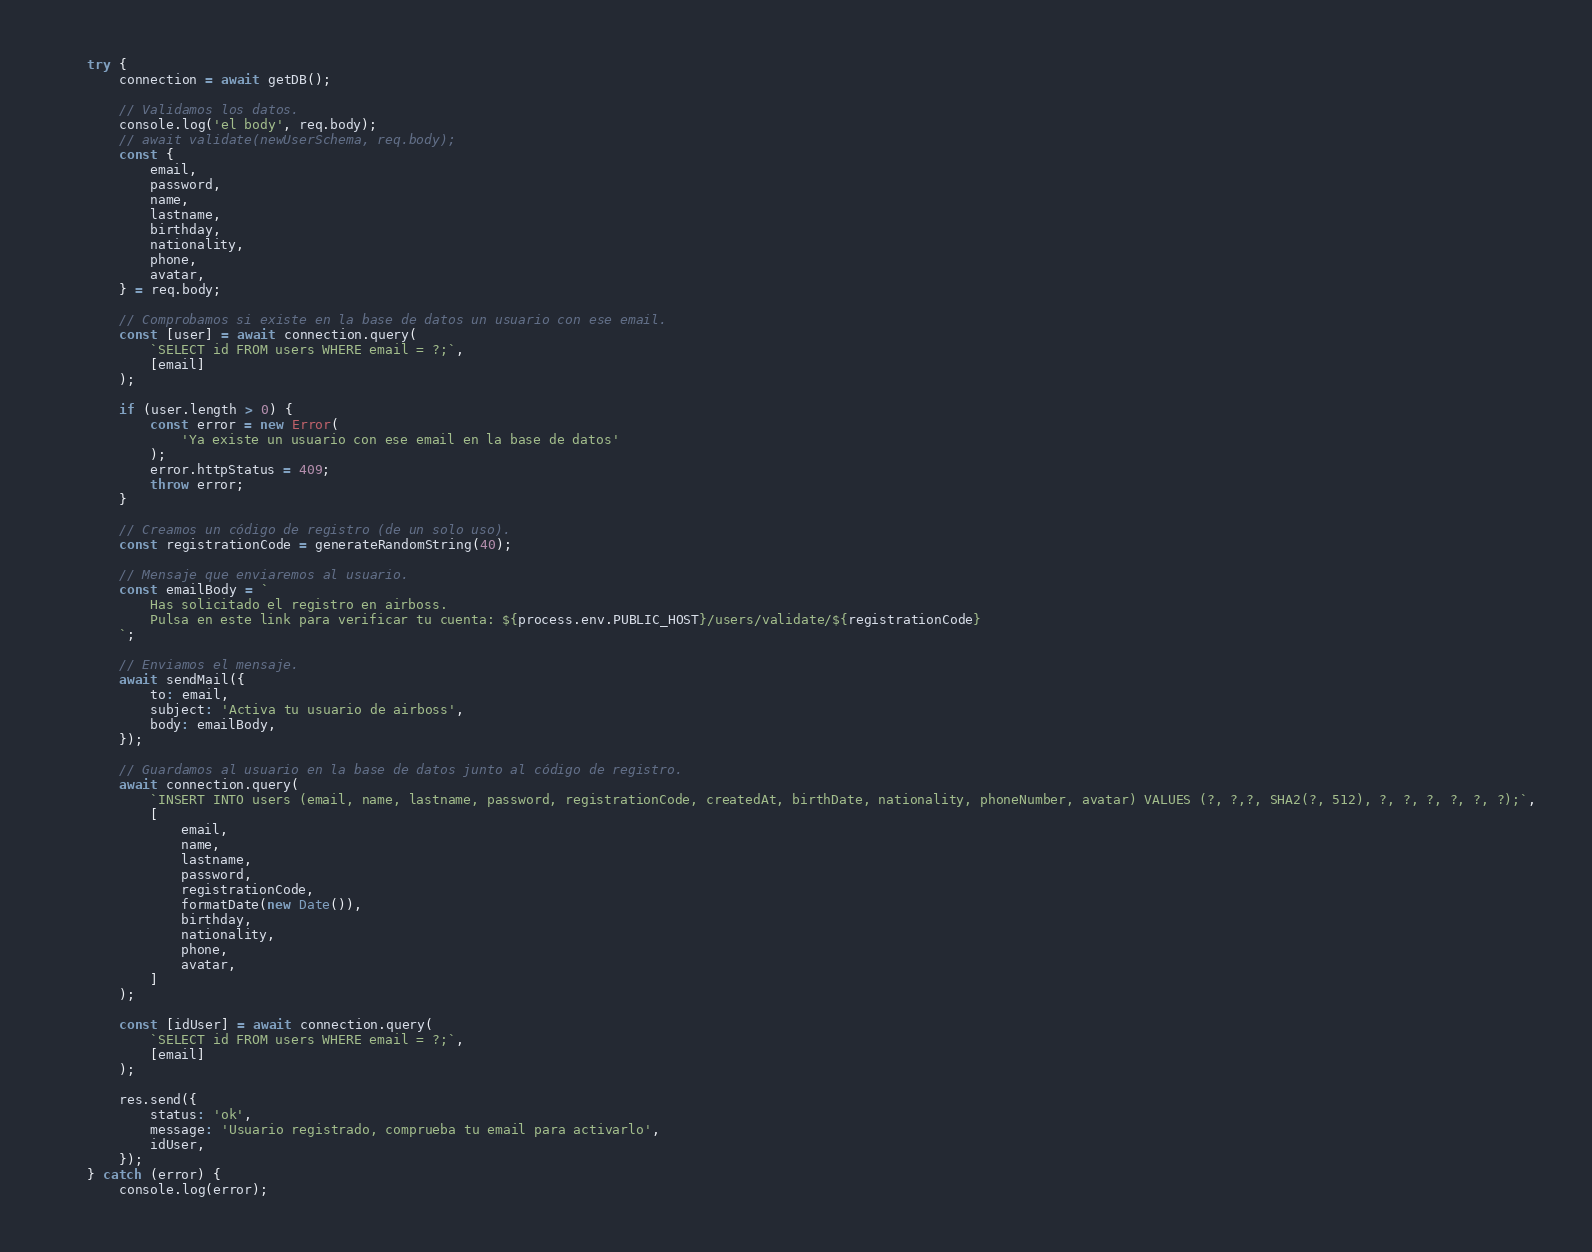Convert code to text. <code><loc_0><loc_0><loc_500><loc_500><_JavaScript_>    try {
        connection = await getDB();

        // Validamos los datos.
        console.log('el body', req.body);
        // await validate(newUserSchema, req.body);
        const {
            email,
            password,
            name,
            lastname,
            birthday,
            nationality,
            phone,
            avatar,
        } = req.body;

        // Comprobamos si existe en la base de datos un usuario con ese email.
        const [user] = await connection.query(
            `SELECT id FROM users WHERE email = ?;`,
            [email]
        );

        if (user.length > 0) {
            const error = new Error(
                'Ya existe un usuario con ese email en la base de datos'
            );
            error.httpStatus = 409;
            throw error;
        }

        // Creamos un código de registro (de un solo uso).
        const registrationCode = generateRandomString(40);

        // Mensaje que enviaremos al usuario.
        const emailBody = `
            Has solicitado el registro en airboss.
            Pulsa en este link para verificar tu cuenta: ${process.env.PUBLIC_HOST}/users/validate/${registrationCode}
        `;

        // Enviamos el mensaje.
        await sendMail({
            to: email,
            subject: 'Activa tu usuario de airboss',
            body: emailBody,
        });

        // Guardamos al usuario en la base de datos junto al código de registro.
        await connection.query(
            `INSERT INTO users (email, name, lastname, password, registrationCode, createdAt, birthDate, nationality, phoneNumber, avatar) VALUES (?, ?,?, SHA2(?, 512), ?, ?, ?, ?, ?, ?);`,
            [
                email,
                name,
                lastname,
                password,
                registrationCode,
                formatDate(new Date()),
                birthday,
                nationality,
                phone,
                avatar,
            ]
        );

        const [idUser] = await connection.query(
            `SELECT id FROM users WHERE email = ?;`,
            [email]
        );

        res.send({
            status: 'ok',
            message: 'Usuario registrado, comprueba tu email para activarlo',
            idUser,
        });
    } catch (error) {
        console.log(error);</code> 